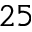<formula> <loc_0><loc_0><loc_500><loc_500>2 5</formula> 